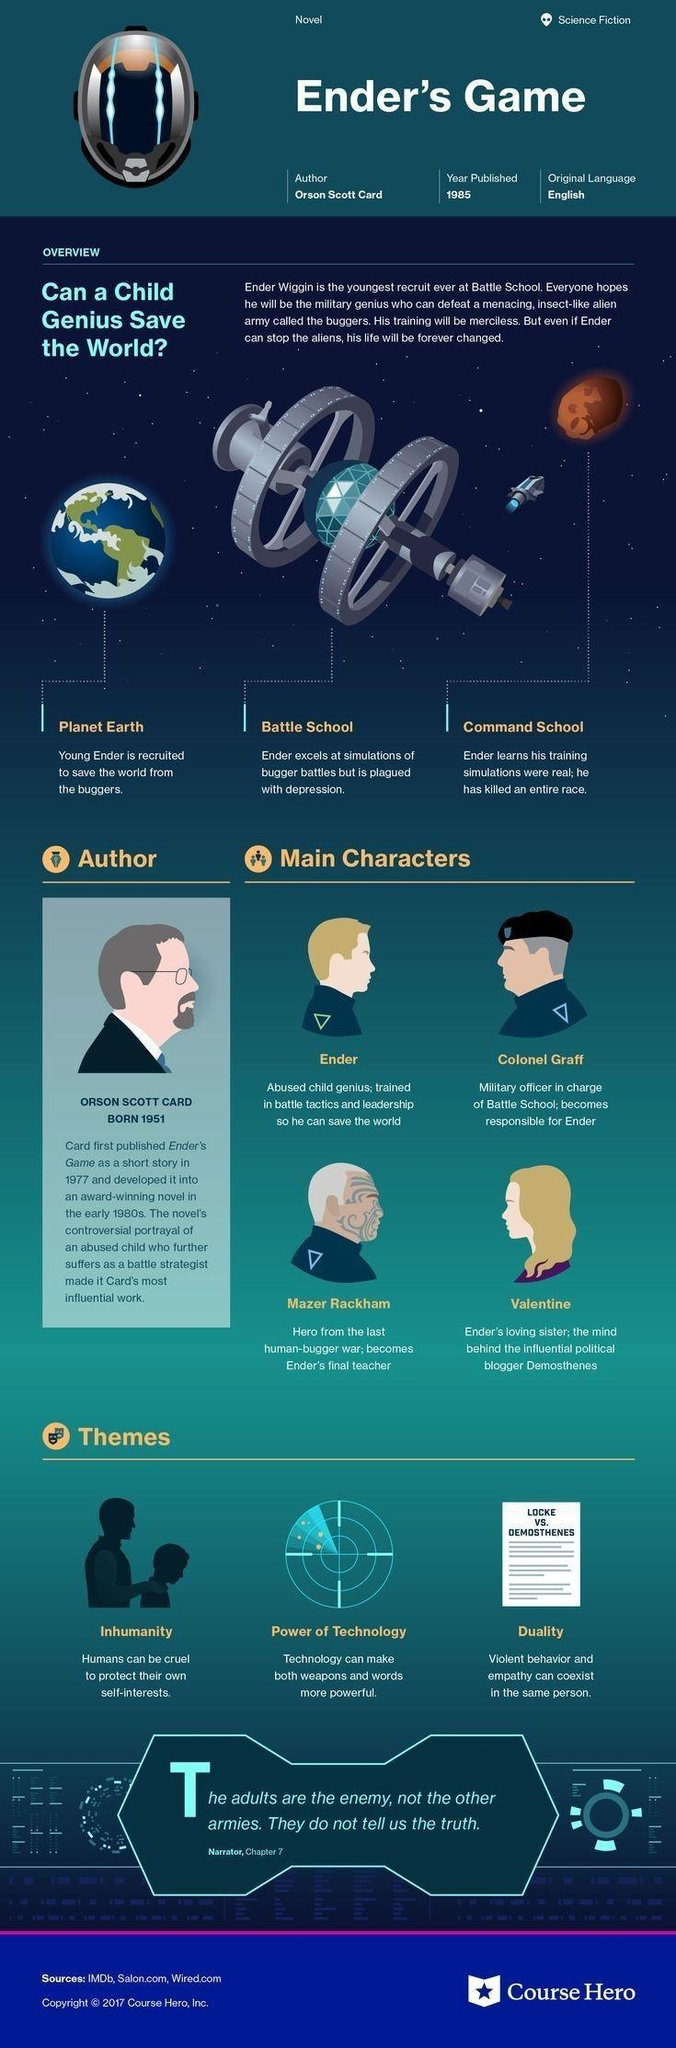What is the third theme of the novel listed in the infographic?
Answer the question with a short phrase. duality Who becomes Ender's final teacher? Mazer Rackham Who becomes responsible for Ender? Colonel Graff Which theme refers to the cruel behavior of humans for self-interest? Inhumanity Who wrote the novel about a child genius recruited to save the earth from the buggers? Orson Scott Card What is the year of publication of the novel named 'Ender's game'? 1985 How many themes pertaining to the novel are mentioned in the infographic? 3 Who is under the guise of the blogger Demosthenes? Valentine What makes words and weapons more powerful? Technology In which language was the novel 'Ender's Game' first published? English 